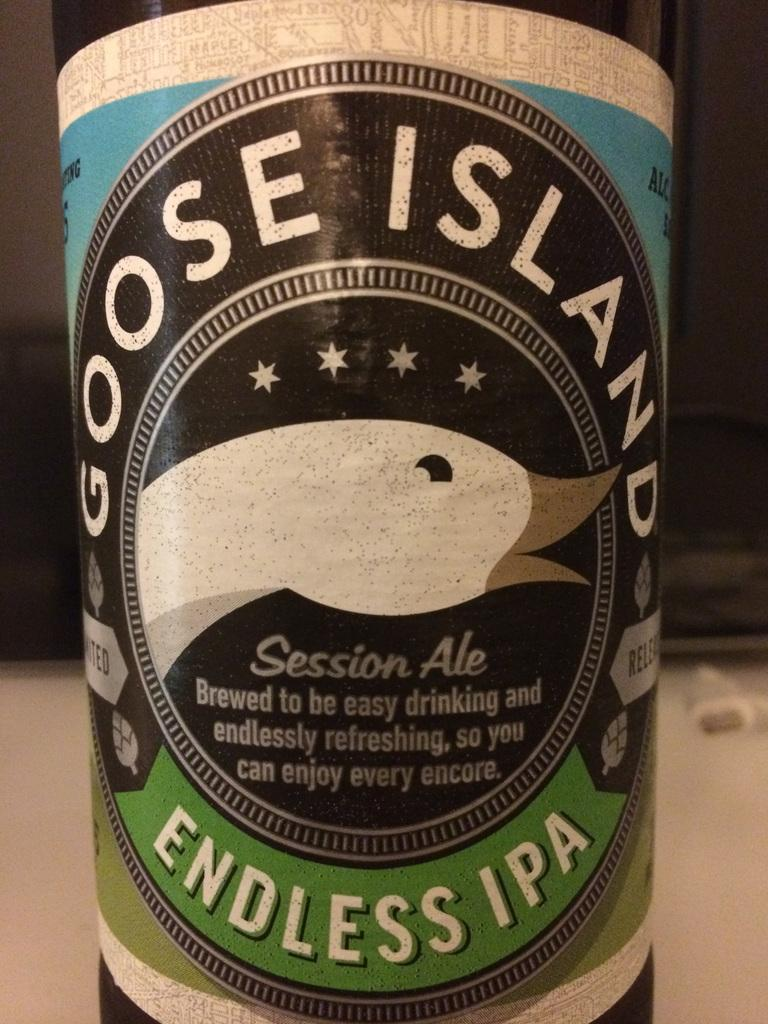<image>
Give a short and clear explanation of the subsequent image. The label of a bottle of Goose Island IPA with a white goose on it. 